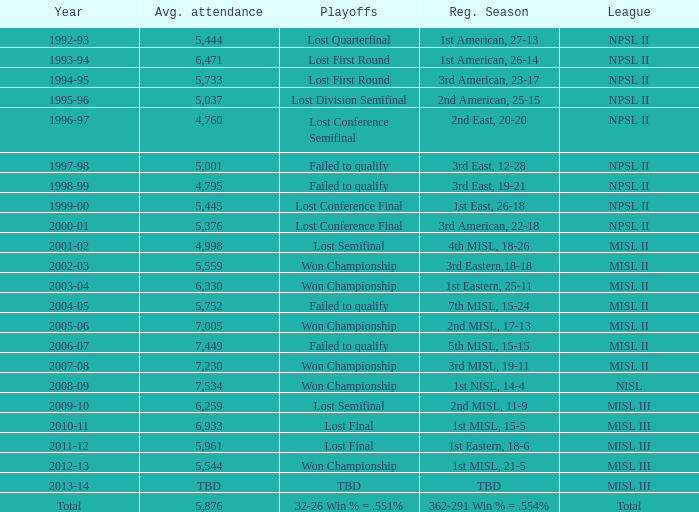When was the year that had an average attendance of 5,445? 1999-00. 